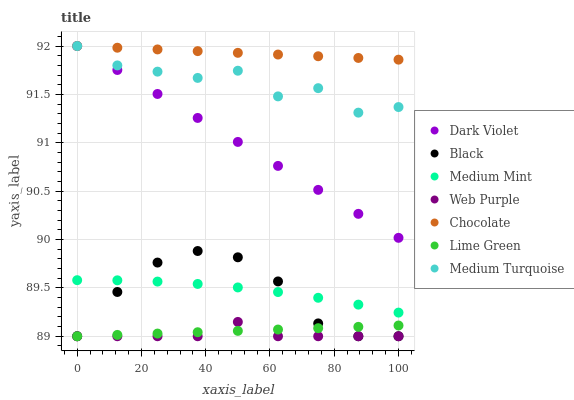Does Web Purple have the minimum area under the curve?
Answer yes or no. Yes. Does Chocolate have the maximum area under the curve?
Answer yes or no. Yes. Does Dark Violet have the minimum area under the curve?
Answer yes or no. No. Does Dark Violet have the maximum area under the curve?
Answer yes or no. No. Is Chocolate the smoothest?
Answer yes or no. Yes. Is Medium Turquoise the roughest?
Answer yes or no. Yes. Is Dark Violet the smoothest?
Answer yes or no. No. Is Dark Violet the roughest?
Answer yes or no. No. Does Web Purple have the lowest value?
Answer yes or no. Yes. Does Dark Violet have the lowest value?
Answer yes or no. No. Does Medium Turquoise have the highest value?
Answer yes or no. Yes. Does Web Purple have the highest value?
Answer yes or no. No. Is Lime Green less than Medium Mint?
Answer yes or no. Yes. Is Medium Turquoise greater than Medium Mint?
Answer yes or no. Yes. Does Chocolate intersect Dark Violet?
Answer yes or no. Yes. Is Chocolate less than Dark Violet?
Answer yes or no. No. Is Chocolate greater than Dark Violet?
Answer yes or no. No. Does Lime Green intersect Medium Mint?
Answer yes or no. No. 